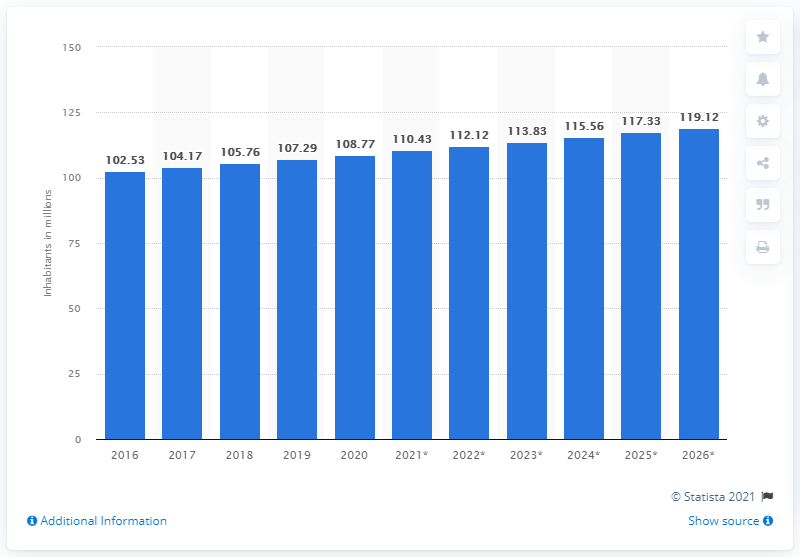Specify some key components in this picture. As of 2019, the population of the Philippines was 107.29 million. 